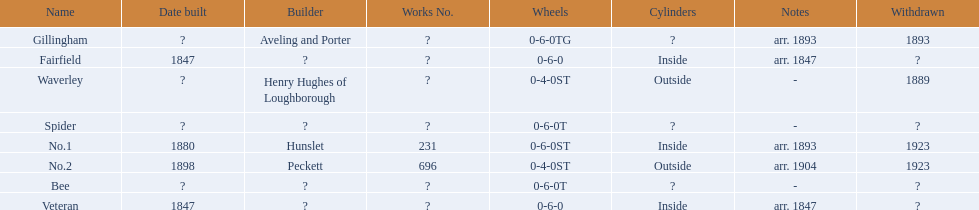What is the total number of names on the chart? 8. 